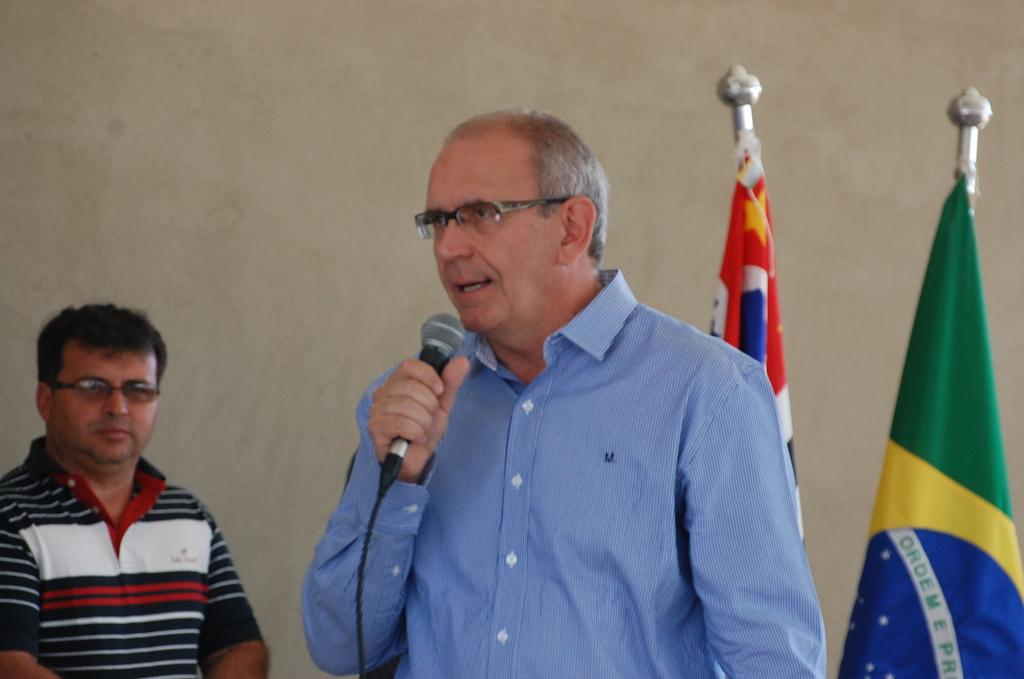Who is the main subject in the image? There is a man in the center of the image. What is the man in the center of the image holding? The man is holding a mic in his hand. What can be seen behind the man in the center of the image? There are flags behind the man. Can you describe the other person in the image? There is another man on the left side of the image. What type of statement is being made by the apparatus on the right side of the image? There is no apparatus present on the right side of the image. How many quarters are visible in the image? There are no quarters visible in the image. 